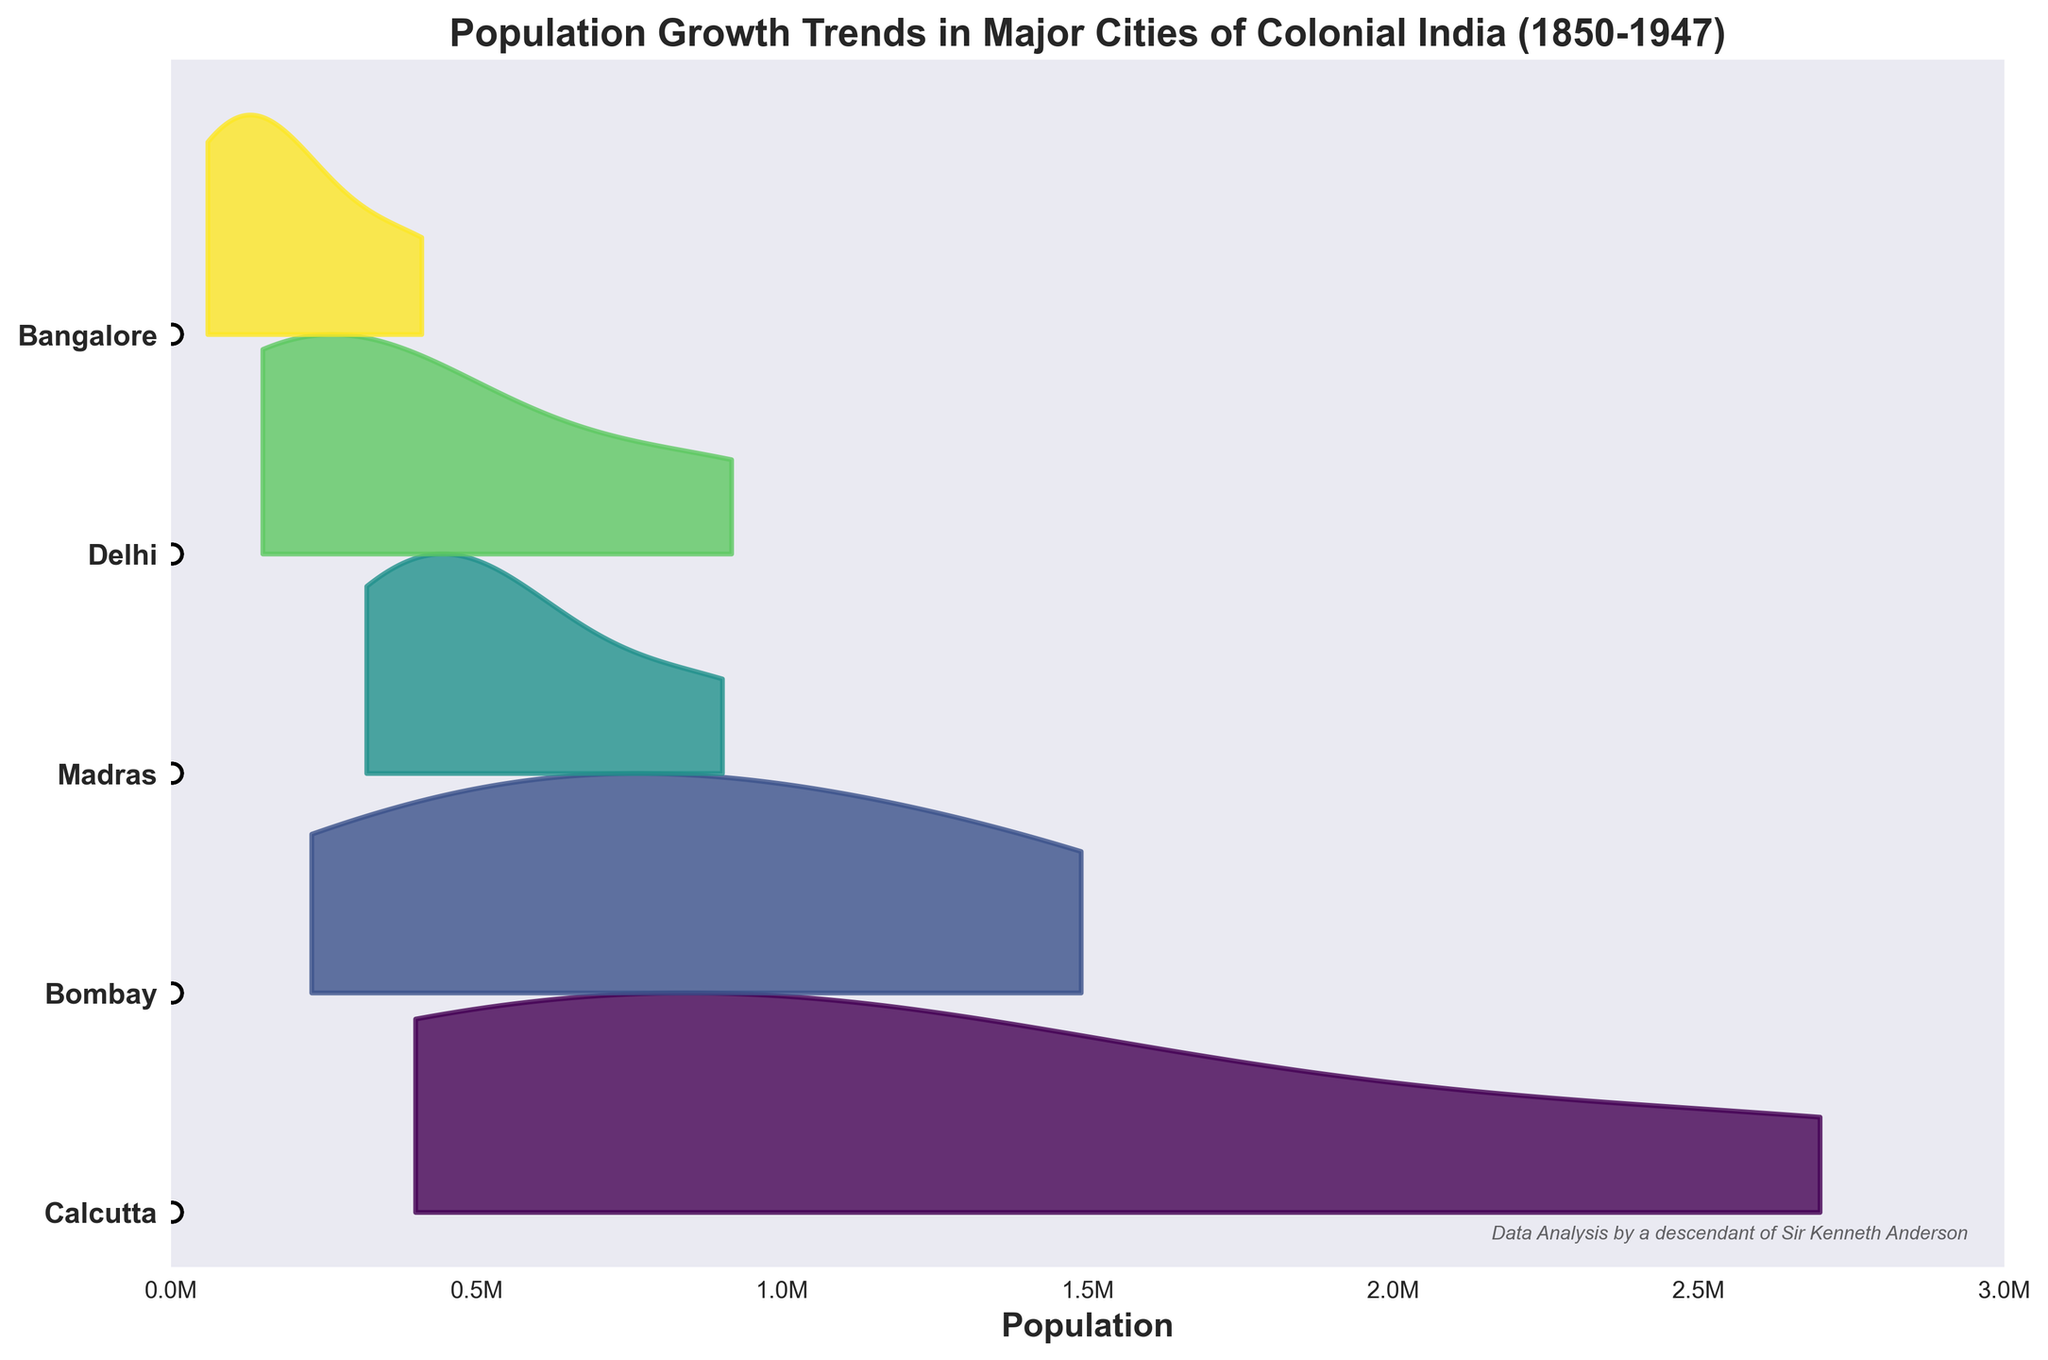What is the title of the figure? The title of the figure is usually prominently displayed at the top. In this case, it is "Population Growth Trends in Major Cities of Colonial India (1850-1947)."
Answer: Population Growth Trends in Major Cities of Colonial India (1850-1947) Which city had the highest recorded population in 1947? By examining the population data points in 1947 along the x-axis, the highest value appears for Calcutta.
Answer: Calcutta How many major cities are represented in the plot? Each row or ridge in the Ridgeline plot represents a different city, which can be counted from the y-axis labels. There are five cities labeled: Calcutta, Bombay, Madras, Delhi, and Bangalore.
Answer: Five Which city had the largest population growth between 1850 and 1947? To find the largest population growth, subtract the 1850 population from the 1947 population for each city and compare the differences. Calcutta's population grew from 400,000 to 2,698,000, the largest increase.
Answer: Calcutta Which city experienced the smallest population growth between 1850 and 1947? Similarly, calculate the population growth for each city. Bangalore's population increased from 60,000 to 410,000, the smallest increase among the cities.
Answer: Bangalore Compare the population growth of Bombay and Madras. Which city had a higher population in 1910 and in 1947? For 1910, compare the population values of Bombay (980,000) and Madras (520,000); Bombay is higher. For 1947, compare the populations of Bombay (1,489,000) and Madras (902,000); Bombay is higher in both years.
Answer: Bombay What is the approximate population range for Delhi in the year 1910? Look at the density curve for Delhi centering around 1910. The range is from about 400,000 to 420,000.
Answer: 400,000 to 420,000 In which year did Madras cross a population of 900,000? By examining the population data points along the x-axis for Madras, it is evident that it crossed 900,000 in 1947.
Answer: 1947 Rank the cities based on their population in the year 1880. Compare the population values for each city in 1880: Calcutta (790,000), Bombay (650,000), Madras (450,000), Delhi (210,000), and Bangalore (120,000). The ranking from highest to lowest is Calcutta, Bombay, Madras, Delhi, and Bangalore.
Answer: Calcutta, Bombay, Madras, Delhi, Bangalore Which city had the fastest population growth relative to its initial population in 1850 by 1947? Calculate the growth rates (final population/initial population) for each city and find the highest. Bangalore had the highest growth rate (410,000 / 60,000 ≈ 6.83).
Answer: Bangalore 